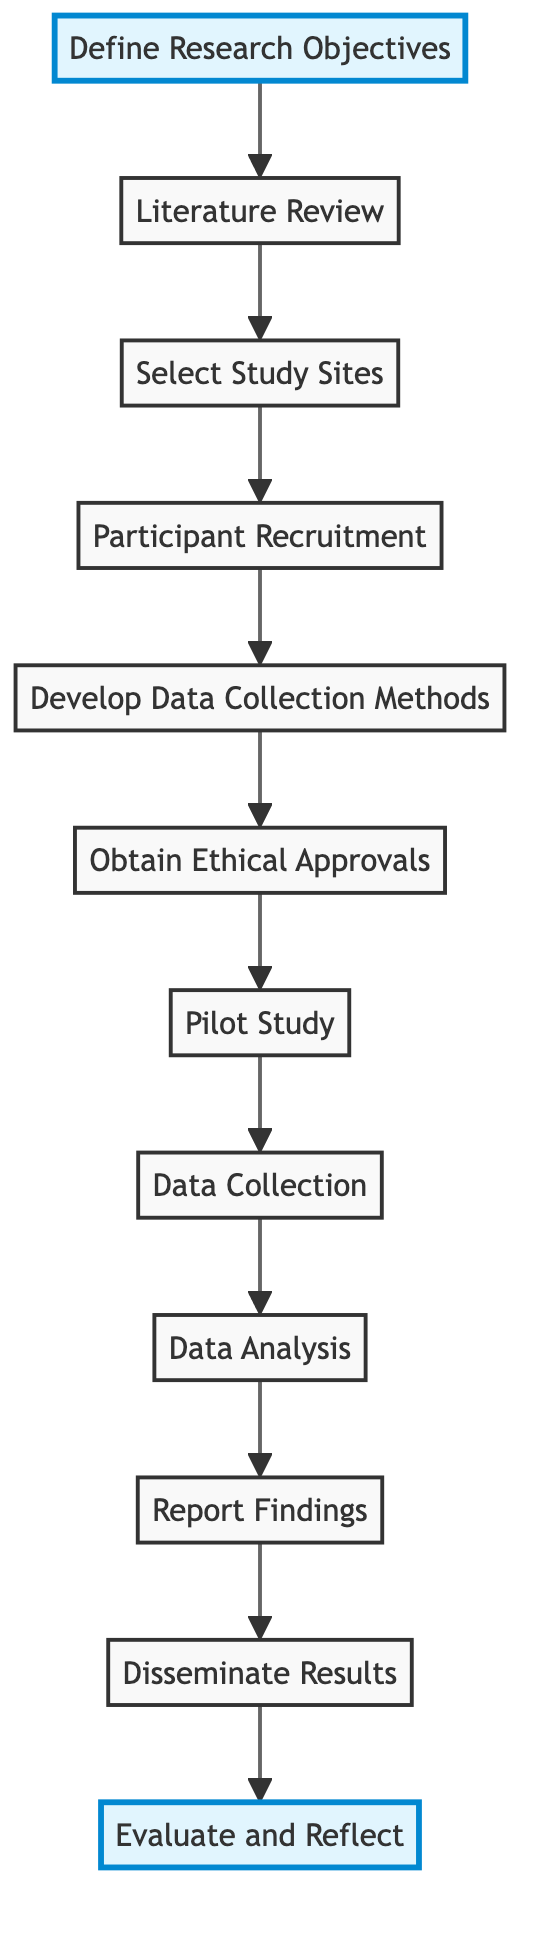What is the first step in the study process? The diagram indicates that the first step is "Define Research Objectives," which is pointed out by the starting node.
Answer: Define Research Objectives How many total steps are in the flowchart? By counting the nodes in the diagram, there are a total of twelve steps represented.
Answer: 12 Which step comes after "Data Analysis"? The flowchart shows that the step following "Data Analysis" is "Report Findings," indicated by the directional arrow leading to that node.
Answer: Report Findings What is the purpose of the "Pilot Study"? According to the description in the diagram, the "Pilot Study" is conducted to test data collection methods and make necessary adjustments, indicating it serves as a trial run.
Answer: Test data collection methods What are the two highlighted steps in the flowchart? The highlighted nodes in the diagram represent "Define Research Objectives" and "Evaluate and Reflect," which are visually emphasized for significance in the study process.
Answer: Define Research Objectives, Evaluate and Reflect What action follows obtaining ethical approvals? The diagram shows that after "Obtain Ethical Approvals," the next step is to conduct a "Pilot Study," establishing the continuity of the research process.
Answer: Pilot Study Which step is directly related to gathering participant data? The step that involves participant data gathering is "Data Collection," which is explicitly mentioned in the diagram following the previous stages.
Answer: Data Collection What is the last step in the research process? The flowchart indicates that the final step is "Evaluate and Reflect," representing the conclusion of the study where outcomes are assessed.
Answer: Evaluate and Reflect How does "Literature Review" contribute to the study? The "Literature Review" informs the research by identifying gaps and refining the research questions, which is important for guiding the subsequent steps in the flowchart.
Answer: Identifying gaps and refining research questions 